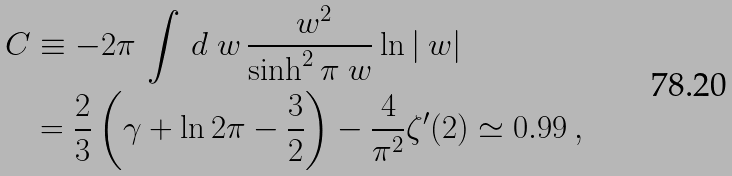Convert formula to latex. <formula><loc_0><loc_0><loc_500><loc_500>C & \equiv - 2 \pi \, \int \, d \ w \, \frac { \ w ^ { 2 } } { \sinh ^ { 2 } \pi \ w } \ln | \ w | \\ & = \frac { 2 } { 3 } \left ( \gamma + \ln 2 \pi - \frac { 3 } { 2 } \right ) - \frac { 4 } { \pi ^ { 2 } } \zeta ^ { \prime } ( 2 ) \simeq 0 . 9 9 \, ,</formula> 